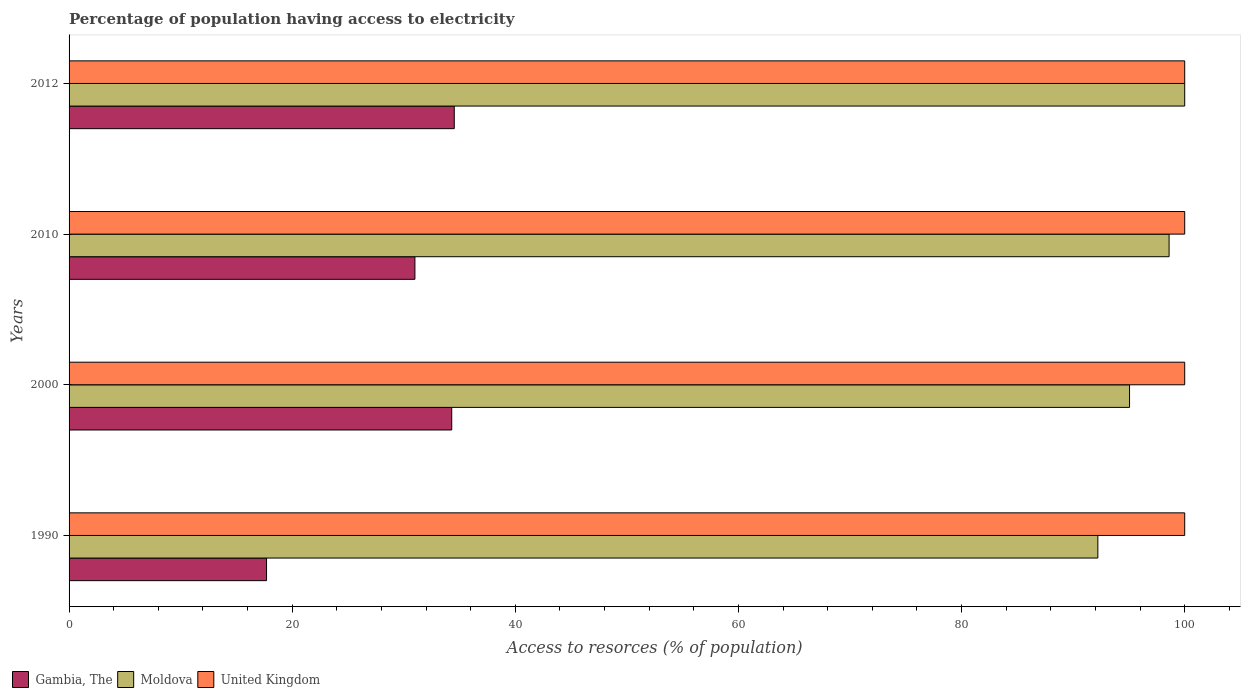Are the number of bars per tick equal to the number of legend labels?
Provide a short and direct response. Yes. How many bars are there on the 3rd tick from the top?
Offer a very short reply. 3. In how many cases, is the number of bars for a given year not equal to the number of legend labels?
Your answer should be very brief. 0. What is the percentage of population having access to electricity in United Kingdom in 2012?
Offer a very short reply. 100. Across all years, what is the maximum percentage of population having access to electricity in Gambia, The?
Keep it short and to the point. 34.53. Across all years, what is the minimum percentage of population having access to electricity in United Kingdom?
Your response must be concise. 100. In which year was the percentage of population having access to electricity in Gambia, The maximum?
Give a very brief answer. 2012. What is the total percentage of population having access to electricity in United Kingdom in the graph?
Provide a succinct answer. 400. What is the difference between the percentage of population having access to electricity in Gambia, The in 2010 and the percentage of population having access to electricity in United Kingdom in 2000?
Ensure brevity in your answer.  -69. What is the average percentage of population having access to electricity in Moldova per year?
Ensure brevity in your answer.  96.47. In the year 1990, what is the difference between the percentage of population having access to electricity in United Kingdom and percentage of population having access to electricity in Gambia, The?
Keep it short and to the point. 82.3. What is the ratio of the percentage of population having access to electricity in Moldova in 2000 to that in 2010?
Give a very brief answer. 0.96. Is the difference between the percentage of population having access to electricity in United Kingdom in 1990 and 2012 greater than the difference between the percentage of population having access to electricity in Gambia, The in 1990 and 2012?
Make the answer very short. Yes. What is the difference between the highest and the second highest percentage of population having access to electricity in Moldova?
Give a very brief answer. 1.4. What is the difference between the highest and the lowest percentage of population having access to electricity in Gambia, The?
Give a very brief answer. 16.83. In how many years, is the percentage of population having access to electricity in United Kingdom greater than the average percentage of population having access to electricity in United Kingdom taken over all years?
Make the answer very short. 0. Is the sum of the percentage of population having access to electricity in Gambia, The in 1990 and 2010 greater than the maximum percentage of population having access to electricity in Moldova across all years?
Ensure brevity in your answer.  No. What does the 3rd bar from the top in 2000 represents?
Offer a terse response. Gambia, The. What does the 1st bar from the bottom in 1990 represents?
Give a very brief answer. Gambia, The. How many bars are there?
Your answer should be very brief. 12. How many years are there in the graph?
Give a very brief answer. 4. Does the graph contain any zero values?
Ensure brevity in your answer.  No. Where does the legend appear in the graph?
Provide a succinct answer. Bottom left. How many legend labels are there?
Offer a very short reply. 3. What is the title of the graph?
Provide a short and direct response. Percentage of population having access to electricity. Does "Peru" appear as one of the legend labels in the graph?
Provide a succinct answer. No. What is the label or title of the X-axis?
Your response must be concise. Access to resorces (% of population). What is the Access to resorces (% of population) of Gambia, The in 1990?
Your response must be concise. 17.7. What is the Access to resorces (% of population) in Moldova in 1990?
Ensure brevity in your answer.  92.22. What is the Access to resorces (% of population) in Gambia, The in 2000?
Give a very brief answer. 34.3. What is the Access to resorces (% of population) of Moldova in 2000?
Offer a terse response. 95.06. What is the Access to resorces (% of population) in Gambia, The in 2010?
Your response must be concise. 31. What is the Access to resorces (% of population) of Moldova in 2010?
Keep it short and to the point. 98.6. What is the Access to resorces (% of population) in Gambia, The in 2012?
Your answer should be compact. 34.53. What is the Access to resorces (% of population) of Moldova in 2012?
Give a very brief answer. 100. What is the Access to resorces (% of population) of United Kingdom in 2012?
Offer a very short reply. 100. Across all years, what is the maximum Access to resorces (% of population) in Gambia, The?
Offer a terse response. 34.53. Across all years, what is the maximum Access to resorces (% of population) of Moldova?
Provide a short and direct response. 100. Across all years, what is the maximum Access to resorces (% of population) in United Kingdom?
Your answer should be compact. 100. Across all years, what is the minimum Access to resorces (% of population) in Moldova?
Offer a terse response. 92.22. What is the total Access to resorces (% of population) in Gambia, The in the graph?
Provide a succinct answer. 117.53. What is the total Access to resorces (% of population) in Moldova in the graph?
Make the answer very short. 385.87. What is the total Access to resorces (% of population) in United Kingdom in the graph?
Your answer should be compact. 400. What is the difference between the Access to resorces (% of population) in Gambia, The in 1990 and that in 2000?
Provide a short and direct response. -16.6. What is the difference between the Access to resorces (% of population) in Moldova in 1990 and that in 2000?
Your answer should be very brief. -2.84. What is the difference between the Access to resorces (% of population) in Moldova in 1990 and that in 2010?
Your response must be concise. -6.38. What is the difference between the Access to resorces (% of population) in United Kingdom in 1990 and that in 2010?
Keep it short and to the point. 0. What is the difference between the Access to resorces (% of population) of Gambia, The in 1990 and that in 2012?
Give a very brief answer. -16.83. What is the difference between the Access to resorces (% of population) of Moldova in 1990 and that in 2012?
Provide a succinct answer. -7.78. What is the difference between the Access to resorces (% of population) of United Kingdom in 1990 and that in 2012?
Provide a succinct answer. 0. What is the difference between the Access to resorces (% of population) in Gambia, The in 2000 and that in 2010?
Your answer should be very brief. 3.3. What is the difference between the Access to resorces (% of population) of Moldova in 2000 and that in 2010?
Keep it short and to the point. -3.54. What is the difference between the Access to resorces (% of population) of Gambia, The in 2000 and that in 2012?
Give a very brief answer. -0.23. What is the difference between the Access to resorces (% of population) of Moldova in 2000 and that in 2012?
Offer a terse response. -4.94. What is the difference between the Access to resorces (% of population) in United Kingdom in 2000 and that in 2012?
Give a very brief answer. 0. What is the difference between the Access to resorces (% of population) of Gambia, The in 2010 and that in 2012?
Ensure brevity in your answer.  -3.53. What is the difference between the Access to resorces (% of population) of United Kingdom in 2010 and that in 2012?
Keep it short and to the point. 0. What is the difference between the Access to resorces (% of population) in Gambia, The in 1990 and the Access to resorces (% of population) in Moldova in 2000?
Your answer should be compact. -77.36. What is the difference between the Access to resorces (% of population) of Gambia, The in 1990 and the Access to resorces (% of population) of United Kingdom in 2000?
Provide a short and direct response. -82.3. What is the difference between the Access to resorces (% of population) of Moldova in 1990 and the Access to resorces (% of population) of United Kingdom in 2000?
Give a very brief answer. -7.78. What is the difference between the Access to resorces (% of population) of Gambia, The in 1990 and the Access to resorces (% of population) of Moldova in 2010?
Your response must be concise. -80.9. What is the difference between the Access to resorces (% of population) in Gambia, The in 1990 and the Access to resorces (% of population) in United Kingdom in 2010?
Your answer should be compact. -82.3. What is the difference between the Access to resorces (% of population) in Moldova in 1990 and the Access to resorces (% of population) in United Kingdom in 2010?
Provide a short and direct response. -7.78. What is the difference between the Access to resorces (% of population) in Gambia, The in 1990 and the Access to resorces (% of population) in Moldova in 2012?
Your answer should be compact. -82.3. What is the difference between the Access to resorces (% of population) of Gambia, The in 1990 and the Access to resorces (% of population) of United Kingdom in 2012?
Your answer should be very brief. -82.3. What is the difference between the Access to resorces (% of population) in Moldova in 1990 and the Access to resorces (% of population) in United Kingdom in 2012?
Your answer should be very brief. -7.78. What is the difference between the Access to resorces (% of population) in Gambia, The in 2000 and the Access to resorces (% of population) in Moldova in 2010?
Your answer should be compact. -64.3. What is the difference between the Access to resorces (% of population) in Gambia, The in 2000 and the Access to resorces (% of population) in United Kingdom in 2010?
Make the answer very short. -65.7. What is the difference between the Access to resorces (% of population) in Moldova in 2000 and the Access to resorces (% of population) in United Kingdom in 2010?
Keep it short and to the point. -4.94. What is the difference between the Access to resorces (% of population) in Gambia, The in 2000 and the Access to resorces (% of population) in Moldova in 2012?
Provide a succinct answer. -65.7. What is the difference between the Access to resorces (% of population) of Gambia, The in 2000 and the Access to resorces (% of population) of United Kingdom in 2012?
Offer a very short reply. -65.7. What is the difference between the Access to resorces (% of population) of Moldova in 2000 and the Access to resorces (% of population) of United Kingdom in 2012?
Offer a terse response. -4.94. What is the difference between the Access to resorces (% of population) in Gambia, The in 2010 and the Access to resorces (% of population) in Moldova in 2012?
Make the answer very short. -69. What is the difference between the Access to resorces (% of population) in Gambia, The in 2010 and the Access to resorces (% of population) in United Kingdom in 2012?
Keep it short and to the point. -69. What is the average Access to resorces (% of population) in Gambia, The per year?
Ensure brevity in your answer.  29.38. What is the average Access to resorces (% of population) of Moldova per year?
Your answer should be very brief. 96.47. What is the average Access to resorces (% of population) in United Kingdom per year?
Your answer should be very brief. 100. In the year 1990, what is the difference between the Access to resorces (% of population) in Gambia, The and Access to resorces (% of population) in Moldova?
Provide a short and direct response. -74.52. In the year 1990, what is the difference between the Access to resorces (% of population) in Gambia, The and Access to resorces (% of population) in United Kingdom?
Your response must be concise. -82.3. In the year 1990, what is the difference between the Access to resorces (% of population) of Moldova and Access to resorces (% of population) of United Kingdom?
Your response must be concise. -7.78. In the year 2000, what is the difference between the Access to resorces (% of population) of Gambia, The and Access to resorces (% of population) of Moldova?
Your response must be concise. -60.76. In the year 2000, what is the difference between the Access to resorces (% of population) of Gambia, The and Access to resorces (% of population) of United Kingdom?
Your answer should be compact. -65.7. In the year 2000, what is the difference between the Access to resorces (% of population) of Moldova and Access to resorces (% of population) of United Kingdom?
Keep it short and to the point. -4.94. In the year 2010, what is the difference between the Access to resorces (% of population) in Gambia, The and Access to resorces (% of population) in Moldova?
Make the answer very short. -67.6. In the year 2010, what is the difference between the Access to resorces (% of population) of Gambia, The and Access to resorces (% of population) of United Kingdom?
Offer a terse response. -69. In the year 2012, what is the difference between the Access to resorces (% of population) of Gambia, The and Access to resorces (% of population) of Moldova?
Give a very brief answer. -65.47. In the year 2012, what is the difference between the Access to resorces (% of population) in Gambia, The and Access to resorces (% of population) in United Kingdom?
Provide a succinct answer. -65.47. What is the ratio of the Access to resorces (% of population) of Gambia, The in 1990 to that in 2000?
Provide a succinct answer. 0.52. What is the ratio of the Access to resorces (% of population) of Moldova in 1990 to that in 2000?
Offer a terse response. 0.97. What is the ratio of the Access to resorces (% of population) of United Kingdom in 1990 to that in 2000?
Provide a succinct answer. 1. What is the ratio of the Access to resorces (% of population) in Gambia, The in 1990 to that in 2010?
Provide a succinct answer. 0.57. What is the ratio of the Access to resorces (% of population) of Moldova in 1990 to that in 2010?
Offer a very short reply. 0.94. What is the ratio of the Access to resorces (% of population) of United Kingdom in 1990 to that in 2010?
Give a very brief answer. 1. What is the ratio of the Access to resorces (% of population) of Gambia, The in 1990 to that in 2012?
Keep it short and to the point. 0.51. What is the ratio of the Access to resorces (% of population) in Moldova in 1990 to that in 2012?
Provide a succinct answer. 0.92. What is the ratio of the Access to resorces (% of population) of United Kingdom in 1990 to that in 2012?
Your answer should be compact. 1. What is the ratio of the Access to resorces (% of population) of Gambia, The in 2000 to that in 2010?
Provide a short and direct response. 1.11. What is the ratio of the Access to resorces (% of population) in Moldova in 2000 to that in 2010?
Your response must be concise. 0.96. What is the ratio of the Access to resorces (% of population) in Gambia, The in 2000 to that in 2012?
Offer a very short reply. 0.99. What is the ratio of the Access to resorces (% of population) in Moldova in 2000 to that in 2012?
Keep it short and to the point. 0.95. What is the ratio of the Access to resorces (% of population) in Gambia, The in 2010 to that in 2012?
Your answer should be very brief. 0.9. What is the ratio of the Access to resorces (% of population) in Moldova in 2010 to that in 2012?
Your answer should be very brief. 0.99. What is the difference between the highest and the second highest Access to resorces (% of population) in Gambia, The?
Give a very brief answer. 0.23. What is the difference between the highest and the second highest Access to resorces (% of population) of Moldova?
Make the answer very short. 1.4. What is the difference between the highest and the lowest Access to resorces (% of population) in Gambia, The?
Give a very brief answer. 16.83. What is the difference between the highest and the lowest Access to resorces (% of population) in Moldova?
Provide a succinct answer. 7.78. What is the difference between the highest and the lowest Access to resorces (% of population) in United Kingdom?
Offer a terse response. 0. 